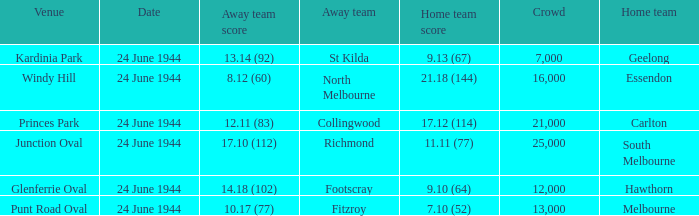Could you parse the entire table? {'header': ['Venue', 'Date', 'Away team score', 'Away team', 'Home team score', 'Crowd', 'Home team'], 'rows': [['Kardinia Park', '24 June 1944', '13.14 (92)', 'St Kilda', '9.13 (67)', '7,000', 'Geelong'], ['Windy Hill', '24 June 1944', '8.12 (60)', 'North Melbourne', '21.18 (144)', '16,000', 'Essendon'], ['Princes Park', '24 June 1944', '12.11 (83)', 'Collingwood', '17.12 (114)', '21,000', 'Carlton'], ['Junction Oval', '24 June 1944', '17.10 (112)', 'Richmond', '11.11 (77)', '25,000', 'South Melbourne'], ['Glenferrie Oval', '24 June 1944', '14.18 (102)', 'Footscray', '9.10 (64)', '12,000', 'Hawthorn'], ['Punt Road Oval', '24 June 1944', '10.17 (77)', 'Fitzroy', '7.10 (52)', '13,000', 'Melbourne']]} When the Crowd was larger than 25,000. what was the Home Team score? None. 